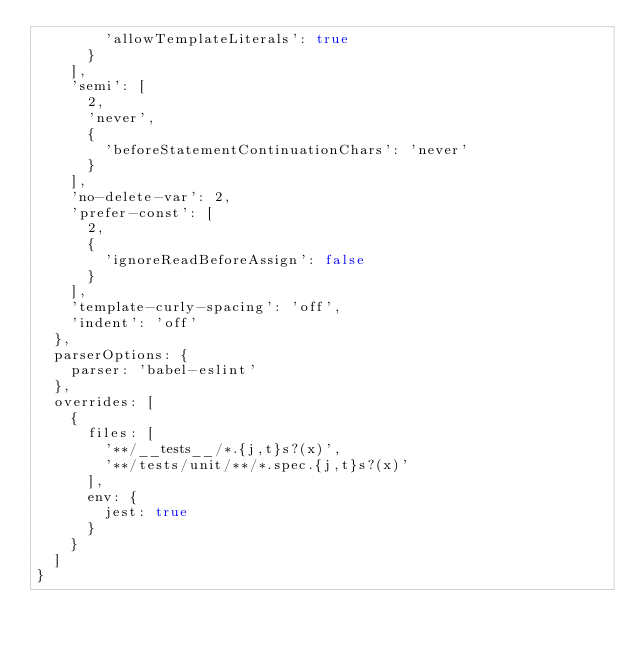Convert code to text. <code><loc_0><loc_0><loc_500><loc_500><_JavaScript_>        'allowTemplateLiterals': true
      }
    ],
    'semi': [
      2,
      'never',
      {
        'beforeStatementContinuationChars': 'never'
      }
    ],
    'no-delete-var': 2,
    'prefer-const': [
      2,
      {
        'ignoreReadBeforeAssign': false
      }
    ],
    'template-curly-spacing': 'off',
    'indent': 'off'
  },
  parserOptions: {
    parser: 'babel-eslint'
  },
  overrides: [
    {
      files: [
        '**/__tests__/*.{j,t}s?(x)',
        '**/tests/unit/**/*.spec.{j,t}s?(x)'
      ],
      env: {
        jest: true
      }
    }
  ]
}
</code> 